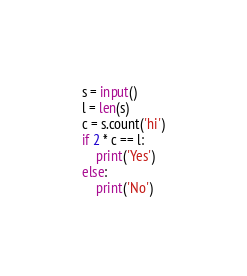<code> <loc_0><loc_0><loc_500><loc_500><_Python_>s = input()
l = len(s)
c = s.count('hi')
if 2 * c == l:
    print('Yes')
else:
    print('No')</code> 